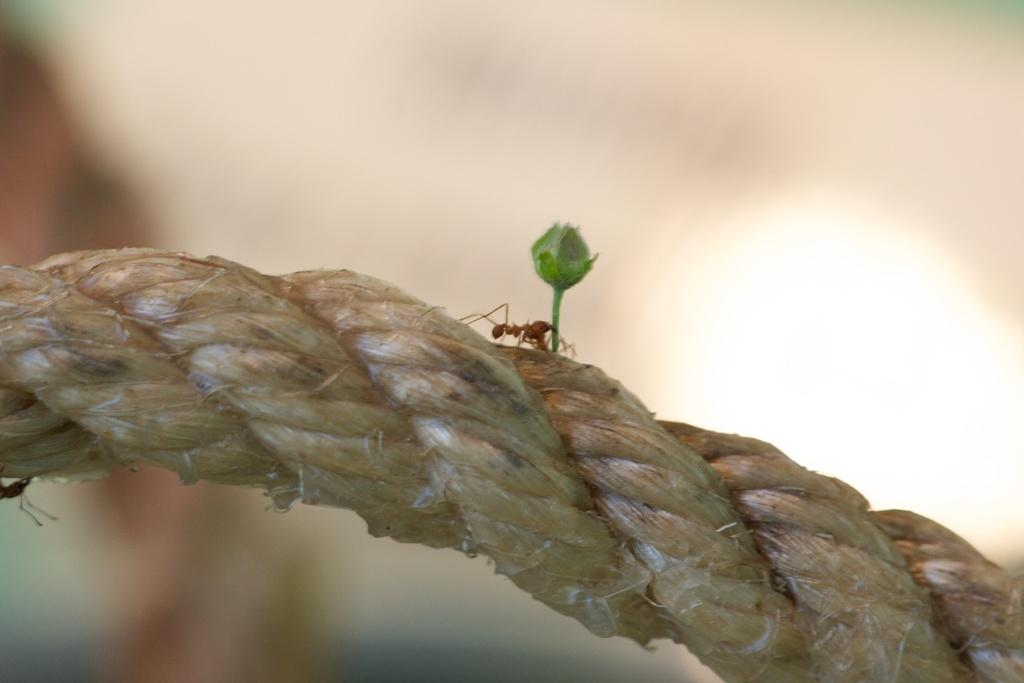What type of insects are present in the image? There are red ants in the image. Where are the ants located? The ants are on a rope in the image. What else can be seen in the image besides the ants? There is a bud in the image. Can you describe the background of the image? The background of the image is blurred. What type of cars can be seen driving in the image? There are no cars present in the image; it features red ants on a rope and a blurred background. What is the current temperature in the image? The image does not provide any information about the temperature, as it focuses on red ants and a rope. 